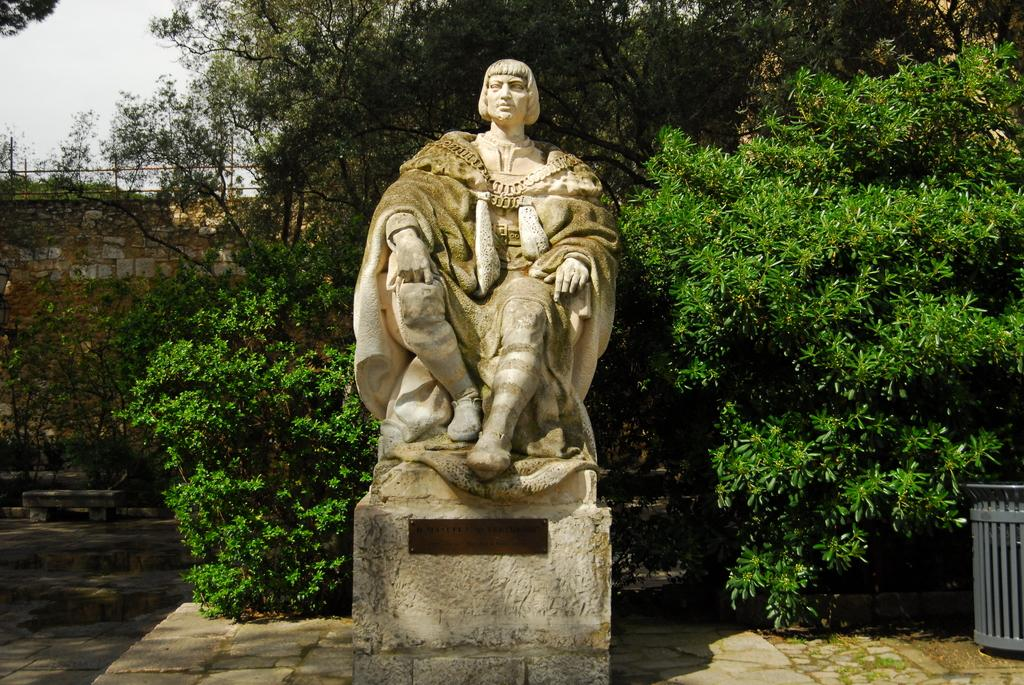What is the main subject in the image? There is a statue in the image. What other objects can be seen in the image? There is a dustbin and trees visible in the image. What type of structure is present in the image? There is a stone wall in the image. What can be seen in the background of the image? The sky is visible in the background of the image. What type of store is located near the statue in the image? There is no store present in the image; it only features a statue, a dustbin, trees, a stone wall, and the sky in the background. 